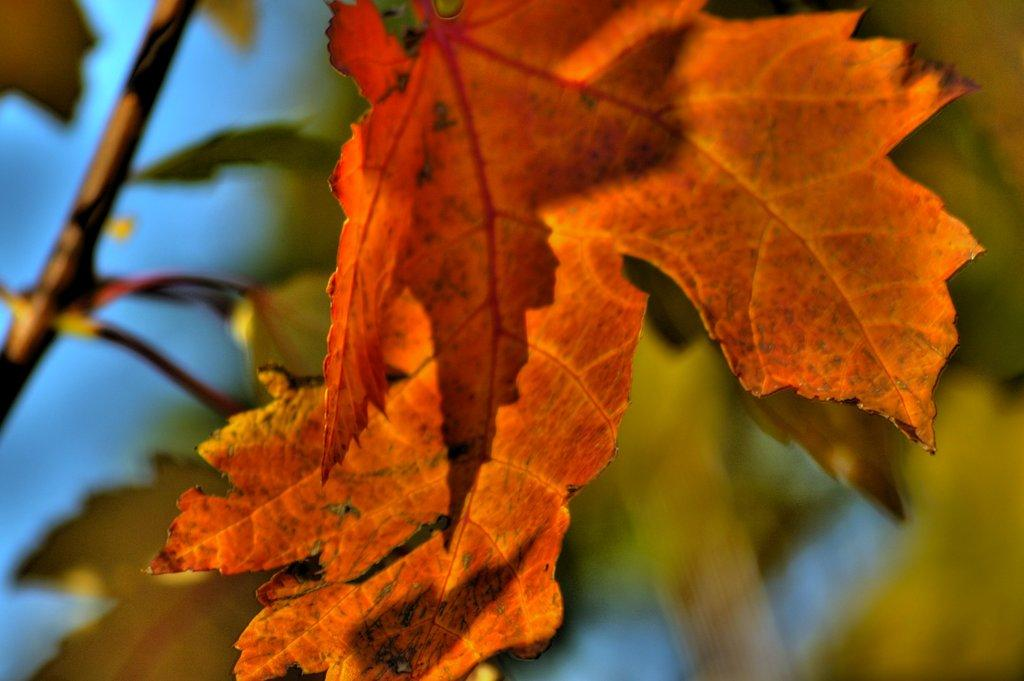What is the main subject of the image? The main subject of the image consists of leaves of a tree. What color are the leaves in the image? The leaves are in orange color. Who is the creator of the poison that can be seen on the leaves in the image? There is no poison present on the leaves in the image, and therefore no creator can be identified. 